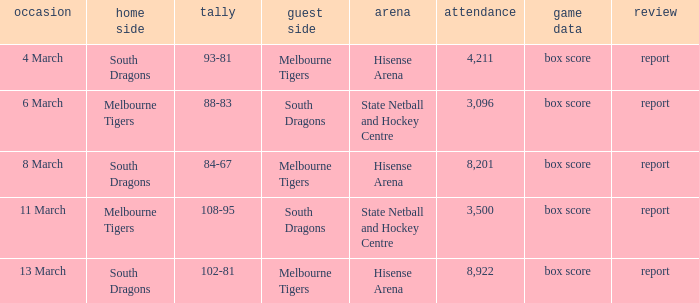Where was the venue with 3,096 in the crowd and against the Melbourne Tigers? Hisense Arena, Hisense Arena, Hisense Arena. 